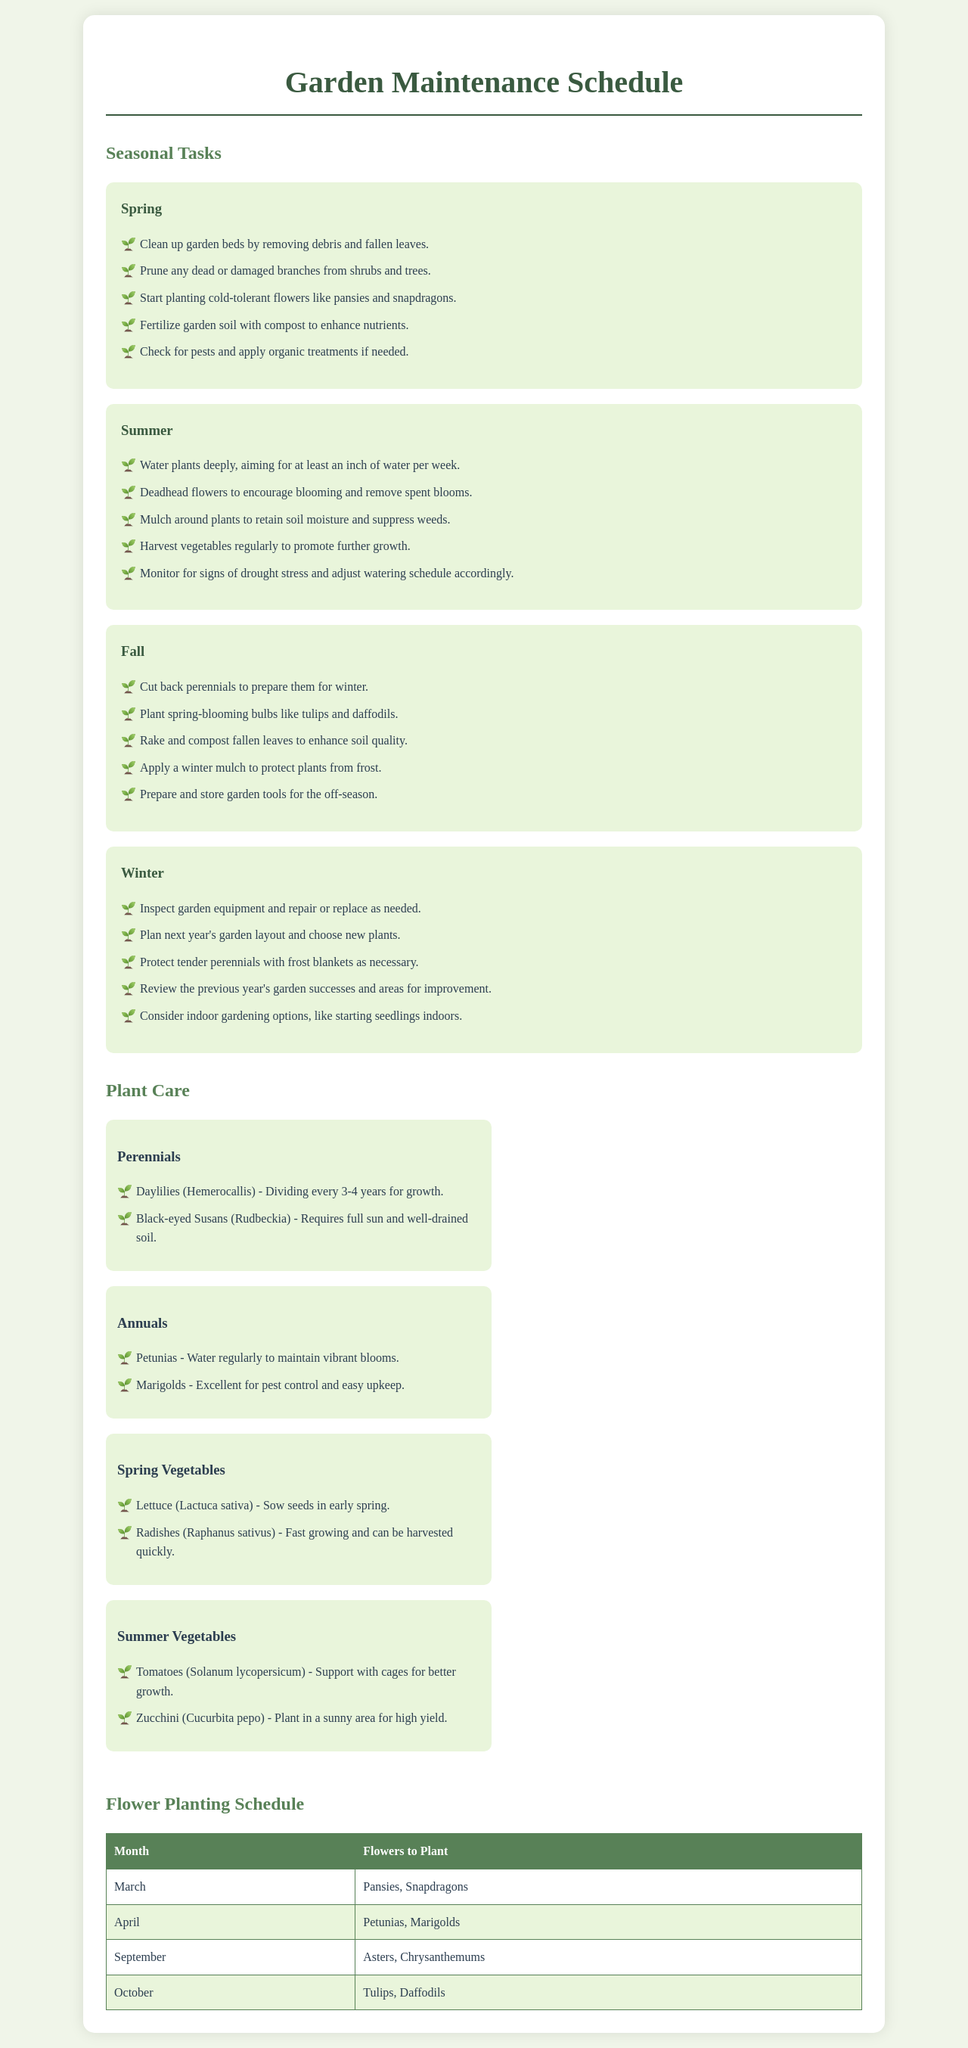What should be done in spring for garden maintenance? The document lists specific tasks to be done in spring, such as cleaning garden beds and planting flowers.
Answer: Clean up garden beds, prune branches, plant cold-tolerant flowers, fertilize soil, check for pests Which flowers are recommended for planting in October? The document specifies the flowers to plant in October in the flower planting schedule.
Answer: Tulips, Daffodils How often should daylilies be divided? The plant care section states the maintenance frequency for daylilies.
Answer: Every 3-4 years What is one task to be performed in winter? The winter tasks include inspecting garden equipment and planning the next gardening year.
Answer: Inspect garden equipment Which month is suggested for planting pansies? The flower planting schedule indicates the month for planting pansies.
Answer: March What type of soil do black-eyed Susans require? The plant care section mentions the soil needs of black-eyed Susans.
Answer: Well-drained soil What should be done with perennials in the fall? The fall tasks include a specific action regarding perennials to prepare them for winter.
Answer: Cut back perennials How should tomatoes be supported for growth? The document provides advice on supporting tomatoes in the plant care section.
Answer: With cages 